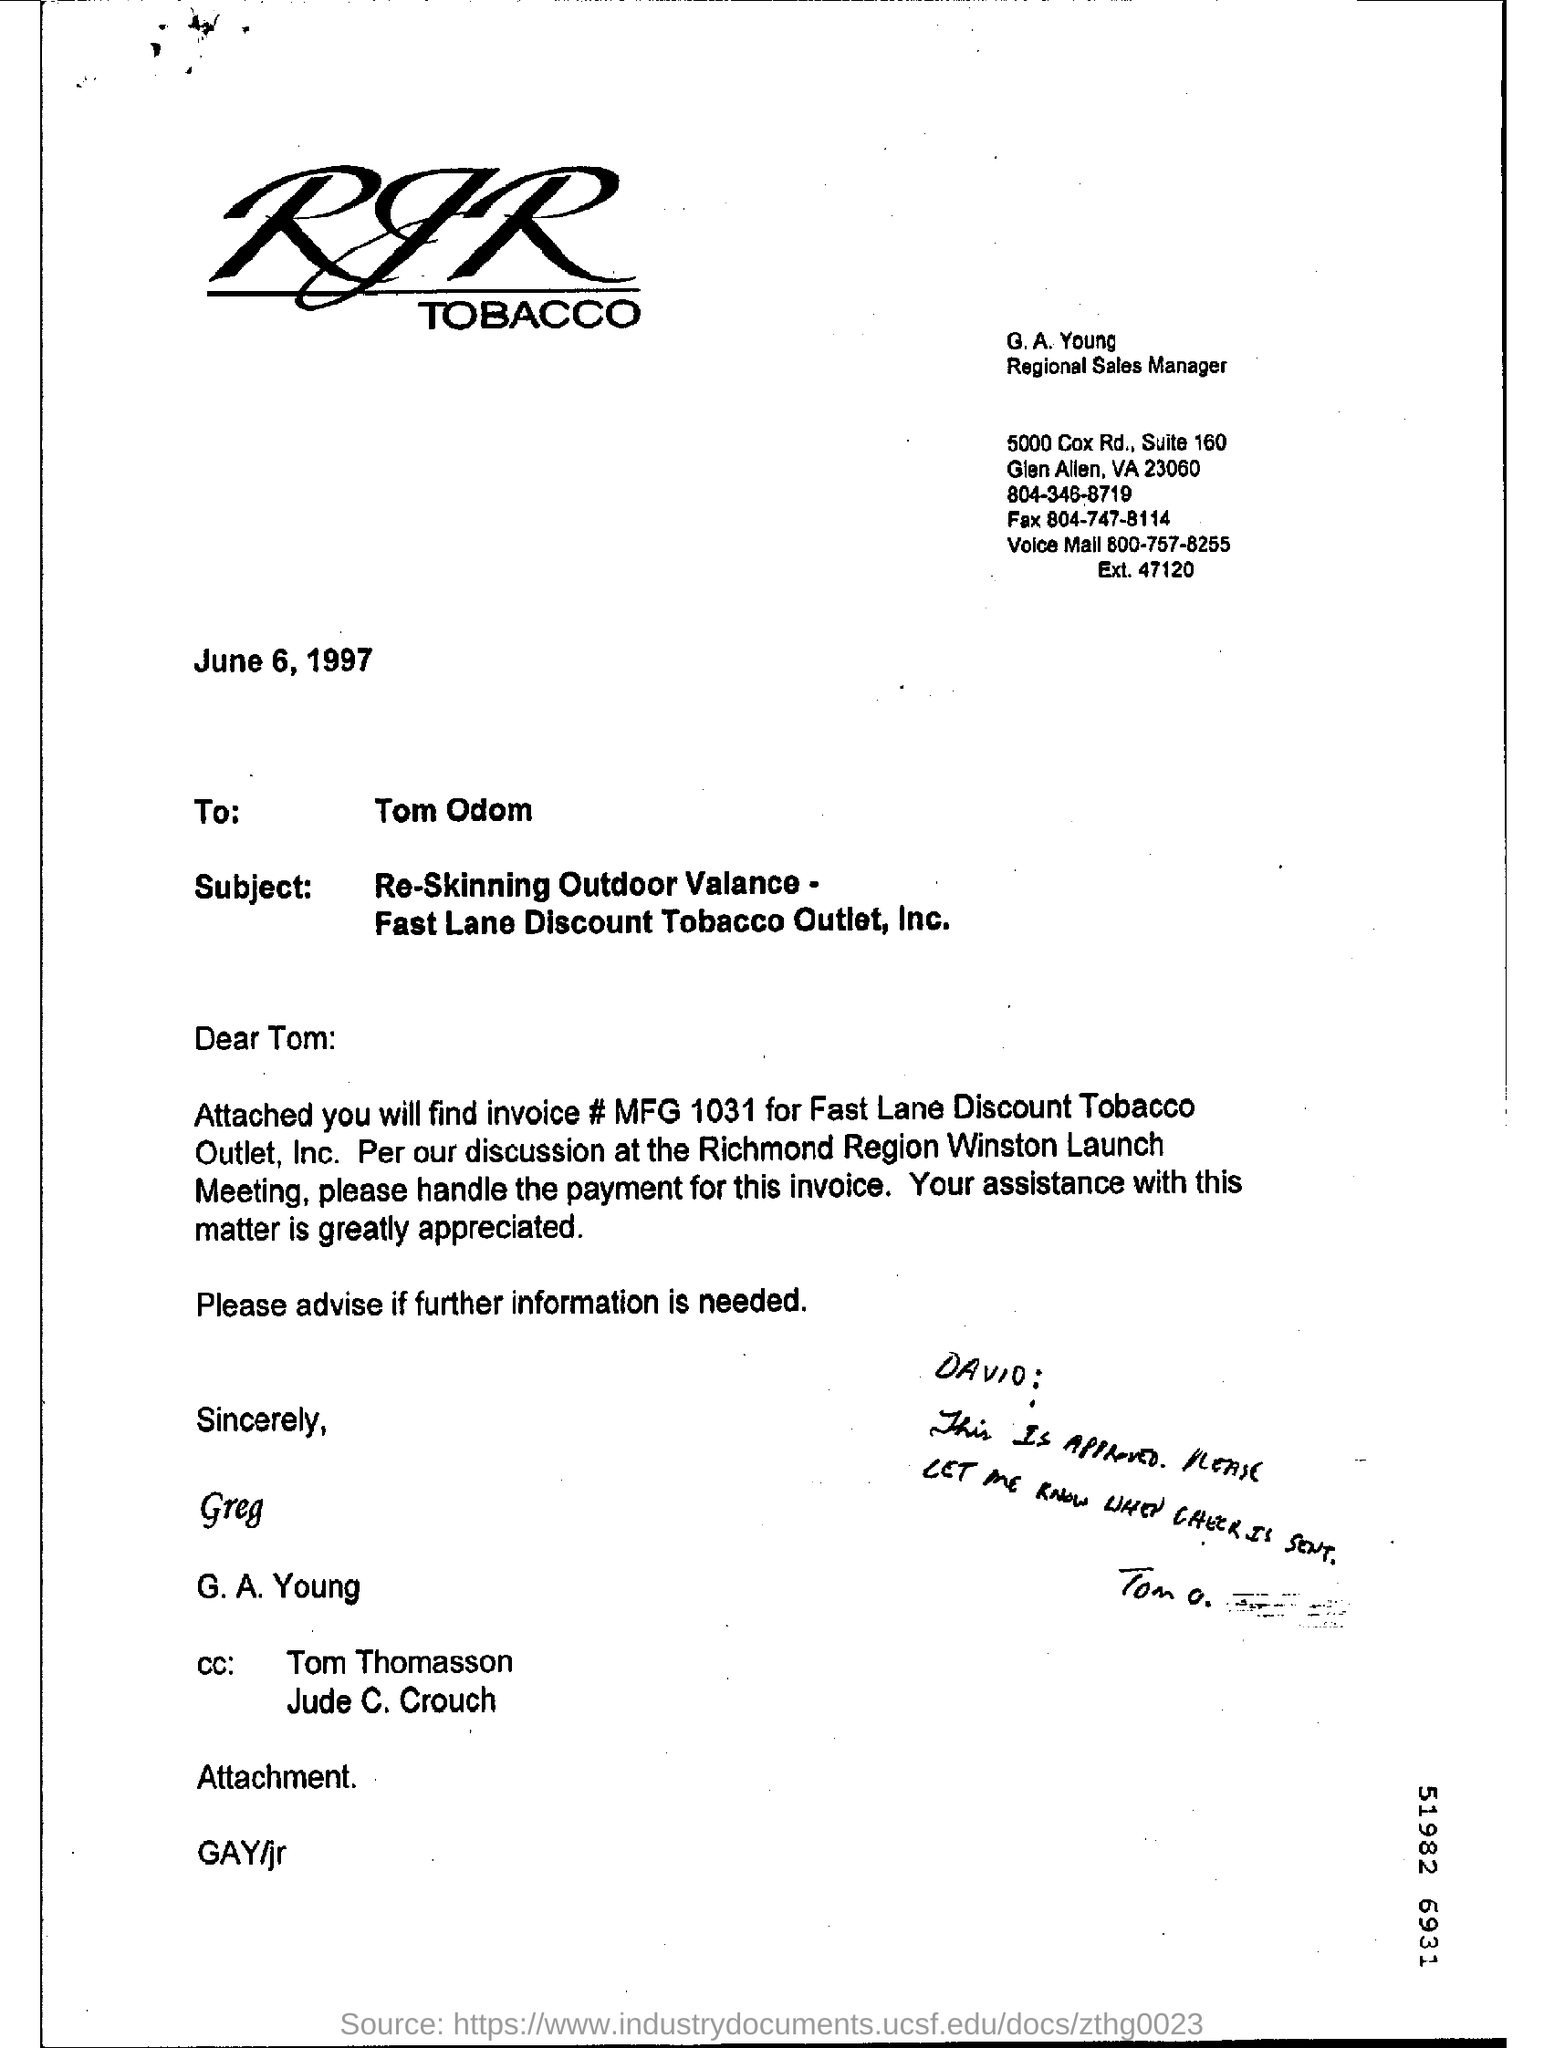Who is G. A. Young?
Keep it short and to the point. Regional Sales Manager. Who is the addressee of this letter?
Your response must be concise. Tom Odom. When is the letter dated?
Provide a short and direct response. June 6, 1997. What is the invoice #  for Fast Lane Discount Tobacco Outlet, Inc. ?
Your response must be concise. MFG 1031. 